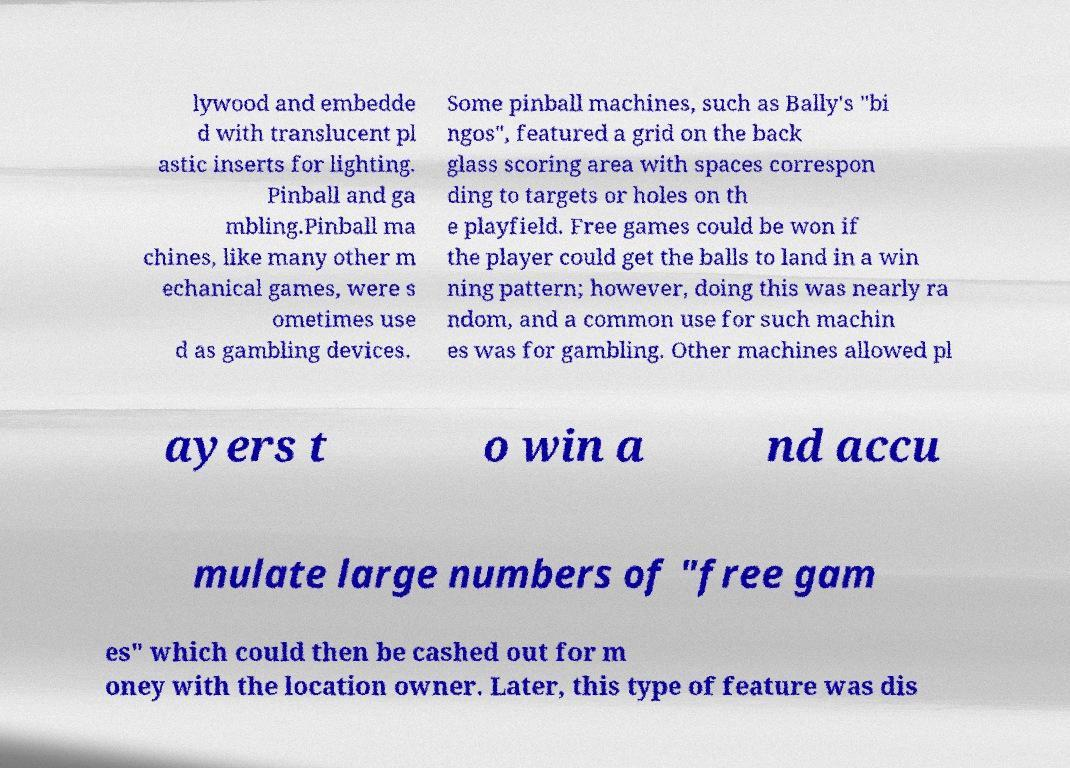There's text embedded in this image that I need extracted. Can you transcribe it verbatim? lywood and embedde d with translucent pl astic inserts for lighting. Pinball and ga mbling.Pinball ma chines, like many other m echanical games, were s ometimes use d as gambling devices. Some pinball machines, such as Bally's "bi ngos", featured a grid on the back glass scoring area with spaces correspon ding to targets or holes on th e playfield. Free games could be won if the player could get the balls to land in a win ning pattern; however, doing this was nearly ra ndom, and a common use for such machin es was for gambling. Other machines allowed pl ayers t o win a nd accu mulate large numbers of "free gam es" which could then be cashed out for m oney with the location owner. Later, this type of feature was dis 